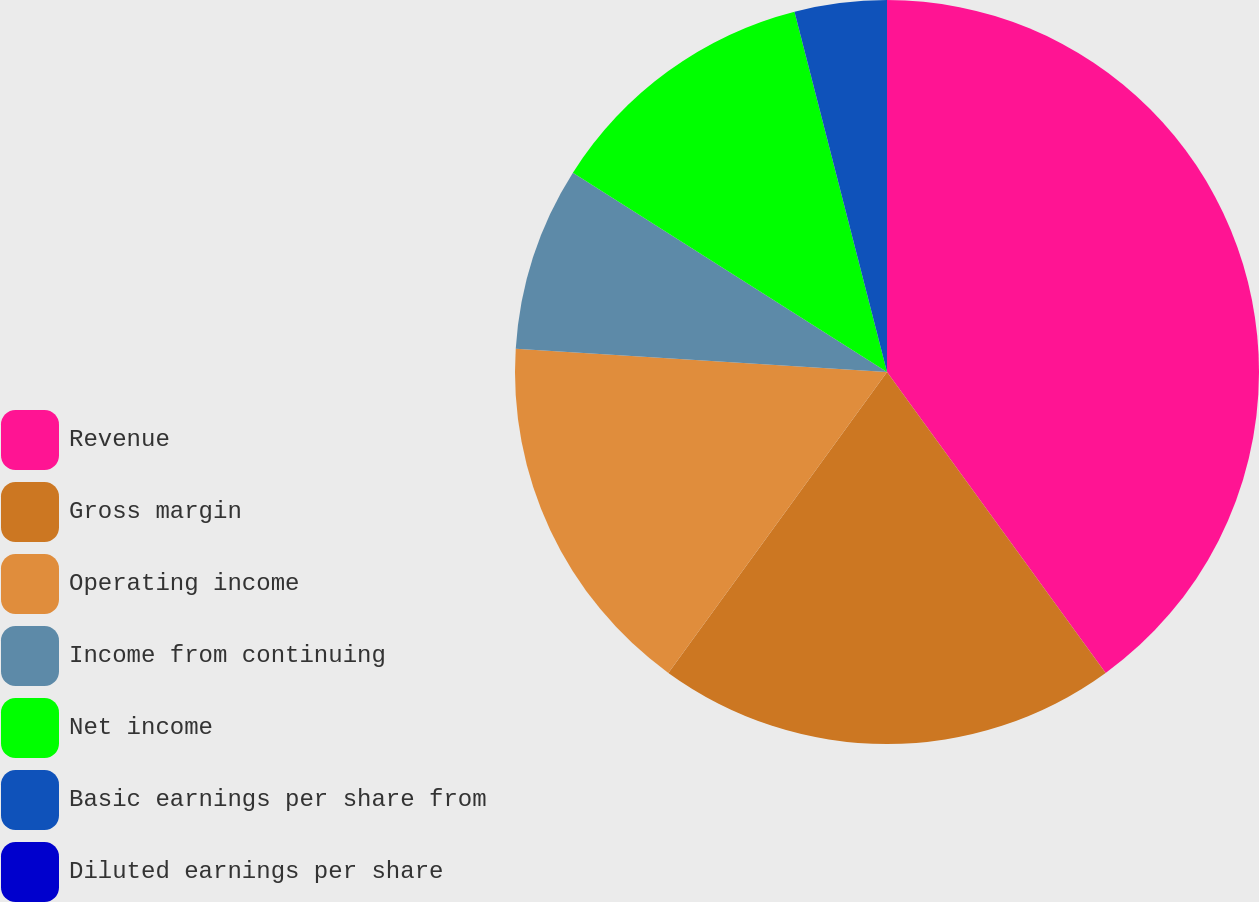<chart> <loc_0><loc_0><loc_500><loc_500><pie_chart><fcel>Revenue<fcel>Gross margin<fcel>Operating income<fcel>Income from continuing<fcel>Net income<fcel>Basic earnings per share from<fcel>Diluted earnings per share<nl><fcel>40.0%<fcel>20.0%<fcel>16.0%<fcel>8.0%<fcel>12.0%<fcel>4.0%<fcel>0.0%<nl></chart> 